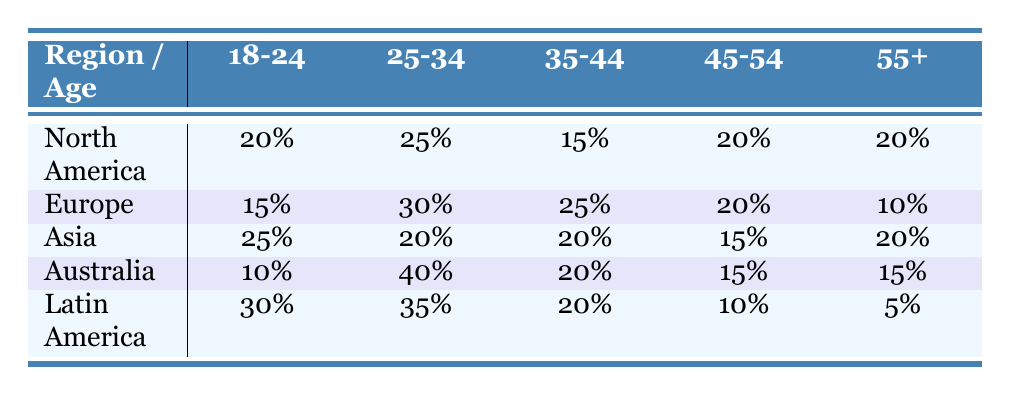What percentage of the audience in Europe is aged 18-24? The table shows that in Europe, the percentage of the audience aged 18-24 is 15%.
Answer: 15% Which region has the highest percentage of participants aged 25-34? Looking at the table, Australia has the highest percentage for the 25-34 age group at 40%.
Answer: Australia What is the total percentage of young adults (18-24 and 25-34) in Latin America? In Latin America, the percentage for 18-24 is 30% and for 25-34 is 35%. Adding these gives a total of 30% + 35% = 65%.
Answer: 65% Is the audience in North America more likely to be aged 45-54 compared to the audience in Asia? In North America, the percentage for 45-54 is 20%, while in Asia, it is 15%. Since 20% is greater than 15%, the statement is true.
Answer: Yes Which age group has the lowest representation in Australia? The table indicates that in Australia, the age group with the lowest percentage is 18-24, which stands at 10%.
Answer: 18-24 What is the average percentage of the audience aged 55+ across all regions? The percentages for 55+ are 20% (North America), 10% (Europe), 20% (Asia), 15% (Australia), and 5% (Latin America). The sum is 20 + 10 + 20 + 15 + 5 = 70%. Since there are 5 regions, the average is 70% / 5 = 14%.
Answer: 14% Does Europe have a higher representation of the 35-44 age group than Latin America? Europe has 25% representation for the 35-44 age group while Latin America has 20%. Since 25% is greater than 20%, the statement is true.
Answer: Yes Which age group in Asia has the same percentage as the 45-54 age group in Europe? In Asia, the percentage for 45-54 is 15%. In Europe, the 45-54 age group also has 15%. Therefore, the age groups are the same percentage.
Answer: 15% 